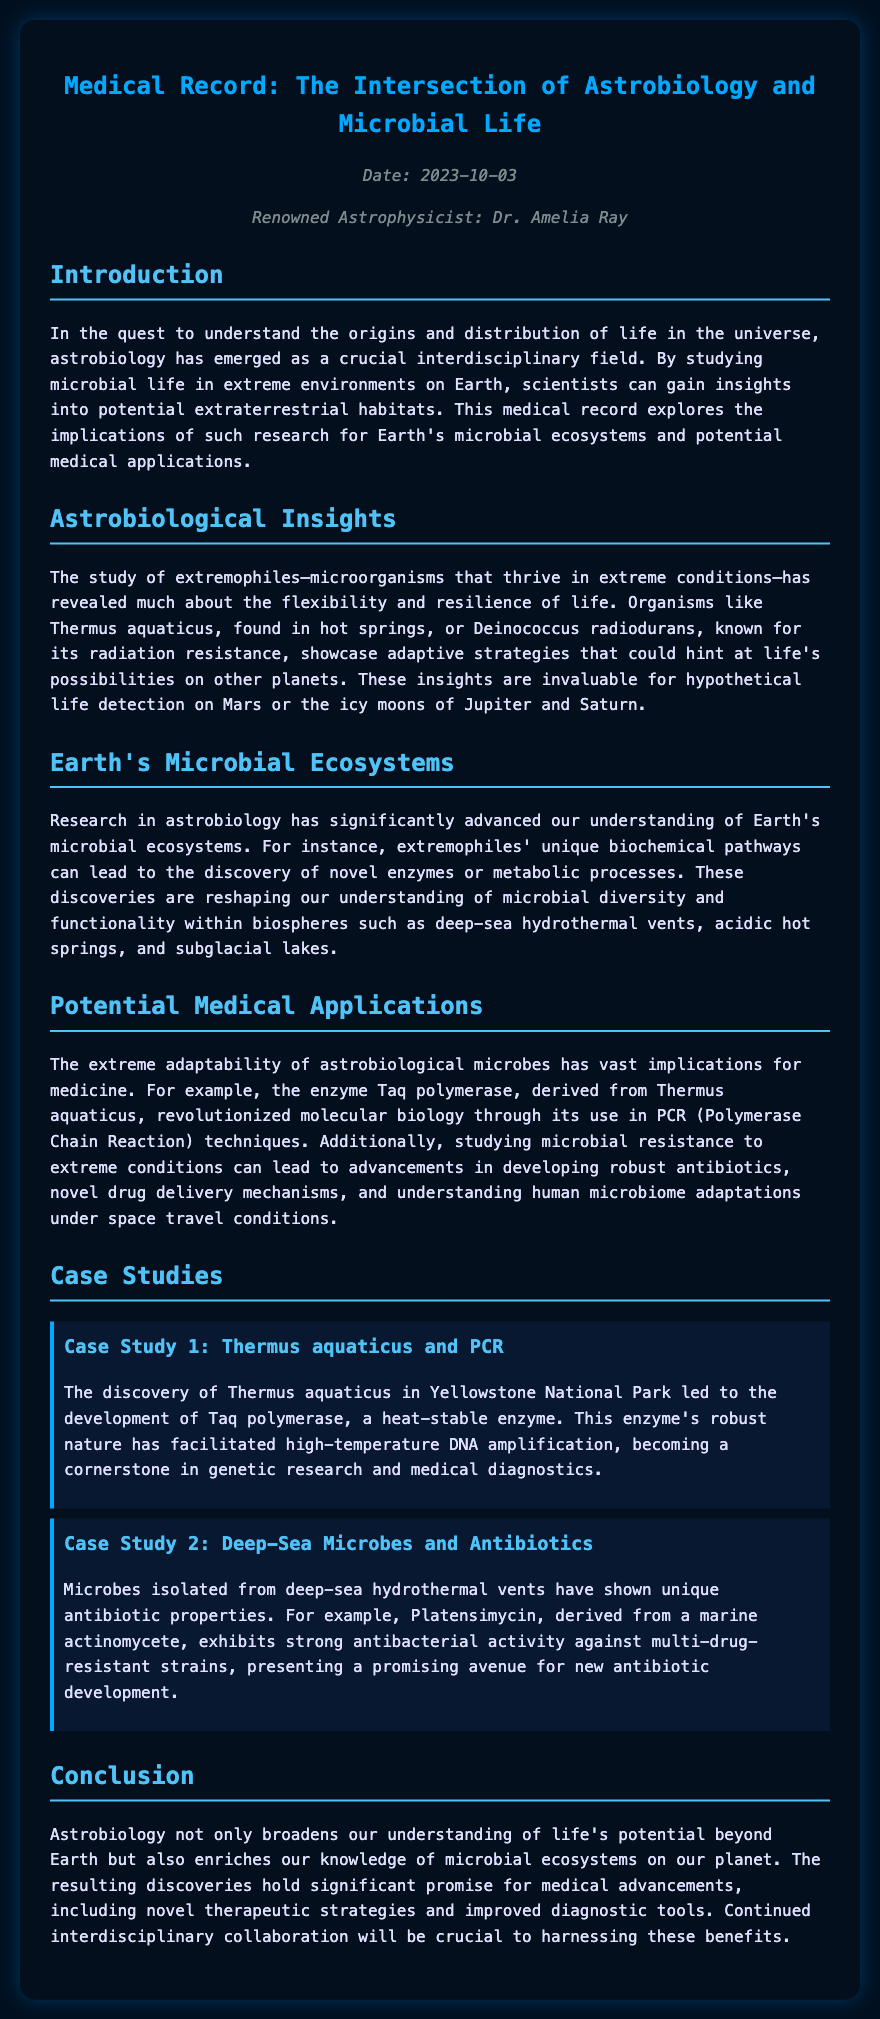What is the title of the document? The title is mentioned prominently at the top of the document, which is "Medical Record: The Intersection of Astrobiology and Microbial Life."
Answer: Medical Record: The Intersection of Astrobiology and Microbial Life Who is the renowned astrophysicist mentioned in the document? The document lists Dr. Amelia Ray as the renowned astrophysicist responsible for this record.
Answer: Dr. Amelia Ray What are extremophiles? Extremophiles are defined in the document as microorganisms that thrive in extreme conditions.
Answer: Microorganisms that thrive in extreme conditions What is an example of an enzyme derived from Thermus aquaticus? The document specifically mentions Taq polymerase as the enzyme derived from Thermus aquaticus.
Answer: Taq polymerase What potential medical application is associated with deep-sea microbes? The document states that deep-sea microbes have shown unique antibiotic properties, indicating a potential medical application.
Answer: Unique antibiotic properties What is the date of the document? The date is noted in the metadata section of the document.
Answer: 2023-10-03 How does studying astrobiological microbes impact antibiotic development? The document explains that studying microbial resistance to extreme conditions can lead to advancements in developing robust antibiotics.
Answer: Advancements in developing robust antibiotics What conclusion is drawn about astrobiology's significance? The document concludes that astrobiology enriches knowledge of microbial ecosystems and holds promise for medical advancements.
Answer: Enriches knowledge of microbial ecosystems and holds promise for medical advancements What is the second case study about? The second case study discusses microbes isolated from deep-sea hydrothermal vents and their antibiotic properties.
Answer: Microbes isolated from deep-sea hydrothermal vents and their antibiotic properties 